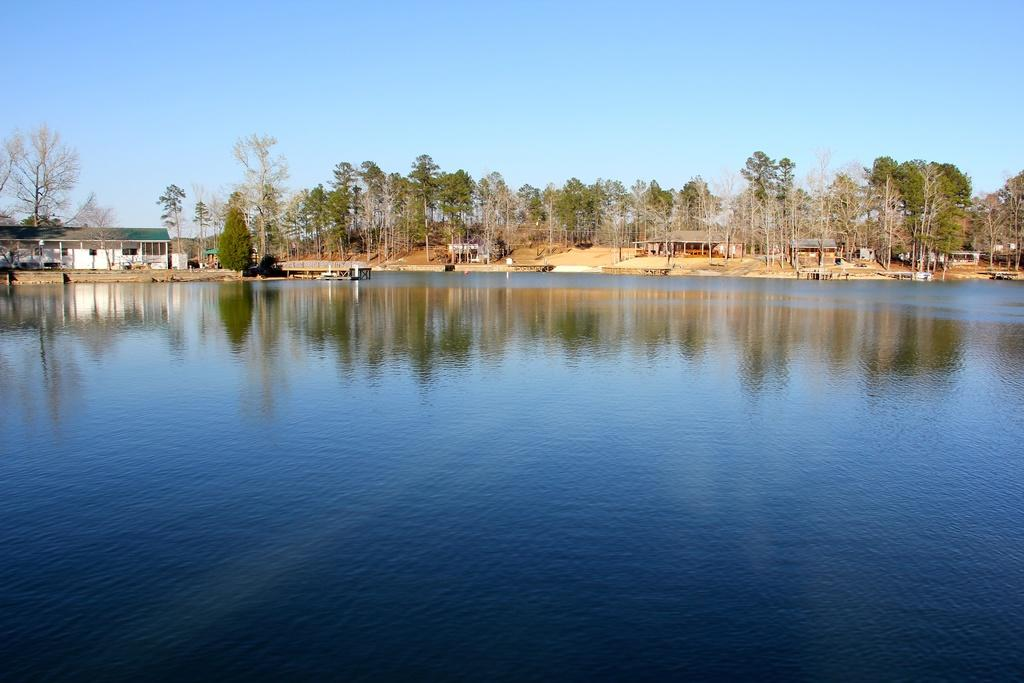What is the main feature of the image? There is a large water body in the image. What type of structures can be seen near the water body? There are houses with roofs in the image. Are there any natural elements present in the image? Yes, there is a group of trees in the image. What is the condition of the sky in the image? The sky is visible and appears cloudy in the image. What type of platform can be seen in the image? There is a deck in the image. What time of day is it in the image, and is there an umbrella present? The time of day cannot be determined from the image, and there is no umbrella present. 